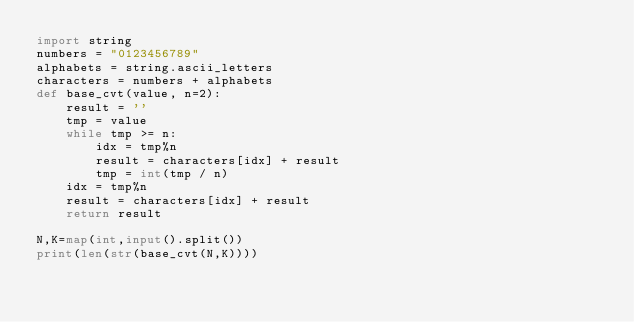<code> <loc_0><loc_0><loc_500><loc_500><_Python_>import string
numbers = "0123456789"
alphabets = string.ascii_letters
characters = numbers + alphabets
def base_cvt(value, n=2):
    result = ''
    tmp = value
    while tmp >= n:
        idx = tmp%n
        result = characters[idx] + result
        tmp = int(tmp / n)
    idx = tmp%n
    result = characters[idx] + result
    return result

N,K=map(int,input().split())
print(len(str(base_cvt(N,K))))

</code> 